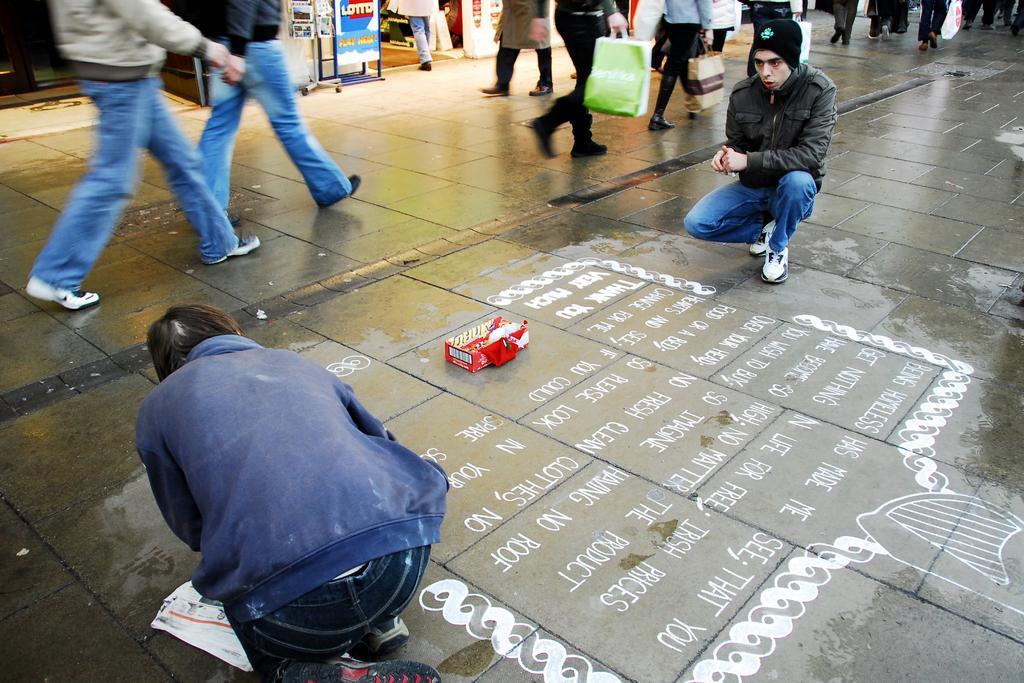Please provide a concise description of this image. This image consists of many people walking on the road. At the bottom, there is a person is drawing on the road is wearing blue color jacket. 